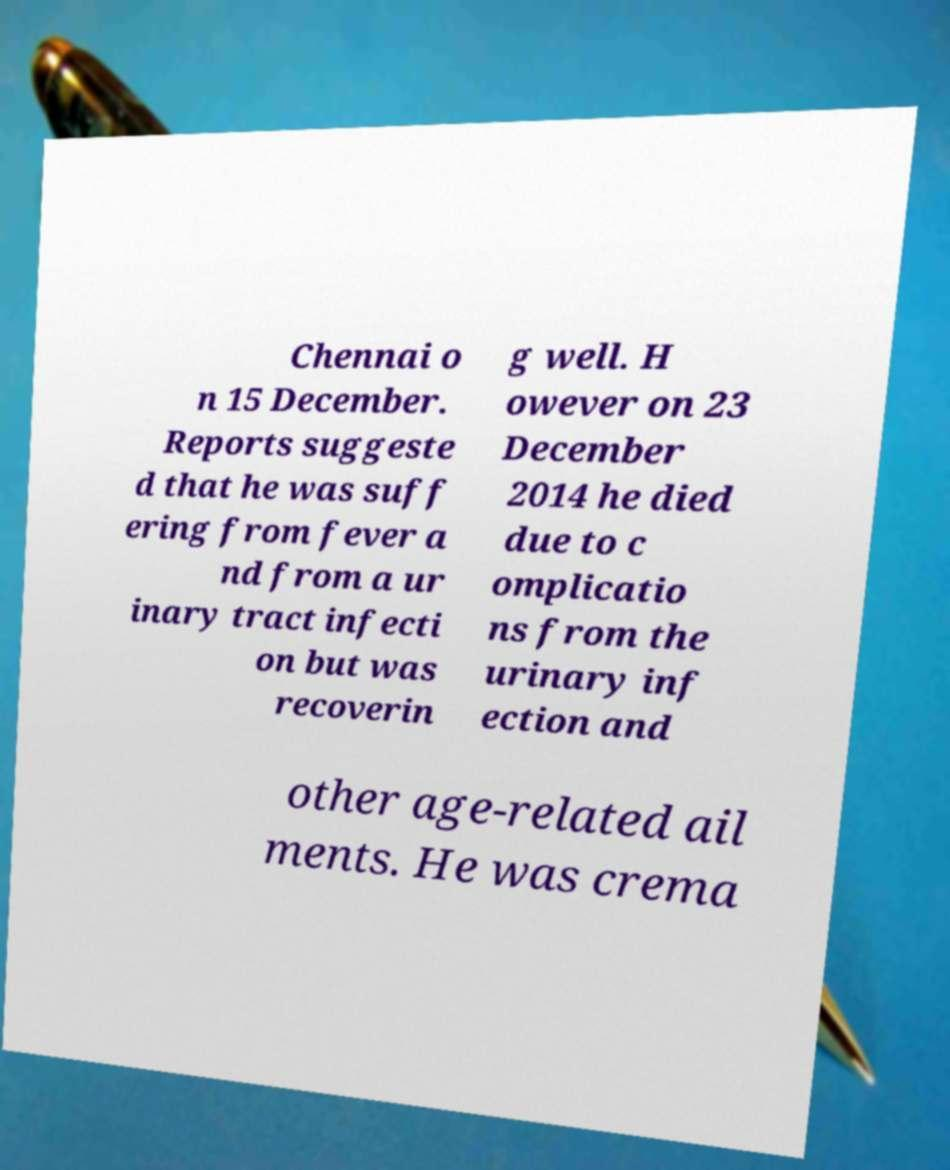For documentation purposes, I need the text within this image transcribed. Could you provide that? Chennai o n 15 December. Reports suggeste d that he was suff ering from fever a nd from a ur inary tract infecti on but was recoverin g well. H owever on 23 December 2014 he died due to c omplicatio ns from the urinary inf ection and other age-related ail ments. He was crema 